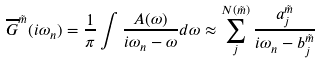<formula> <loc_0><loc_0><loc_500><loc_500>\overline { G } ^ { \tilde { m } } ( i \omega _ { n } ) = \frac { 1 } { \pi } \int \frac { A ( \omega ) } { i \omega _ { n } - \omega } d \omega \approx \sum _ { j } ^ { N ( \tilde { m } ) } \frac { a _ { j } ^ { \tilde { m } } } { i \omega _ { n } - b _ { j } ^ { \tilde { m } } }</formula> 